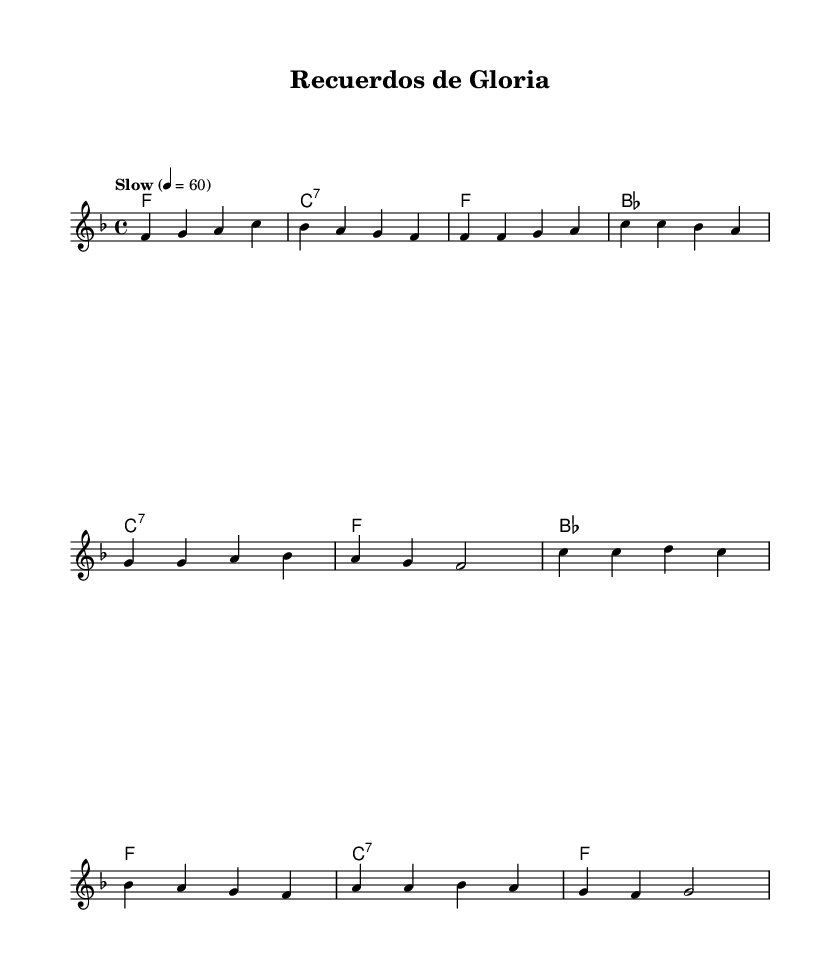What is the key signature of this music? The key signature is F major, which has one flat (B♭). This is deduced from the initial section of the music sheet that indicates the key.
Answer: F major What is the time signature of this piece? The time signature is 4/4, which is shown at the beginning of the score. This means there are four beats in each measure, and each beat is a quarter note.
Answer: 4/4 What is the tempo marking for this piece? The tempo marking states "Slow" and is set to a metronome marking of 60 beats per minute, indicated at the top of the score.
Answer: Slow, 60 How many measures does the verse section contain? The verse section consists of four measures, as identified by counting the number of measures outlined in the melody part labeled as the verse.
Answer: 4 What is the final chord of the chorus? The final chord of the chorus is F major, which can be identified from the chord progression in the harmonies section right before the end of the chorus.
Answer: F How many notes are in the introductory measure of the melody? The introductory measure contains four notes, specifically F, G, A, and C, as seen in the first measure of the melody.
Answer: 4 What type of music is this piece categorized as? This piece is categorized as a bolero ballad. The style is suggested by the slow tempo, melodic structure, and nostalgic theme reflecting on past glory.
Answer: Bolero ballad 